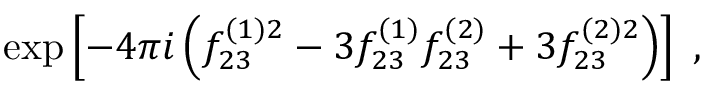Convert formula to latex. <formula><loc_0><loc_0><loc_500><loc_500>\exp \left [ - 4 \pi i \left ( f _ { 2 3 } ^ { ( 1 ) 2 } - 3 f _ { 2 3 } ^ { ( 1 ) } f _ { 2 3 } ^ { ( 2 ) } + 3 f _ { 2 3 } ^ { ( 2 ) 2 } \right ) \right ] \, ,</formula> 